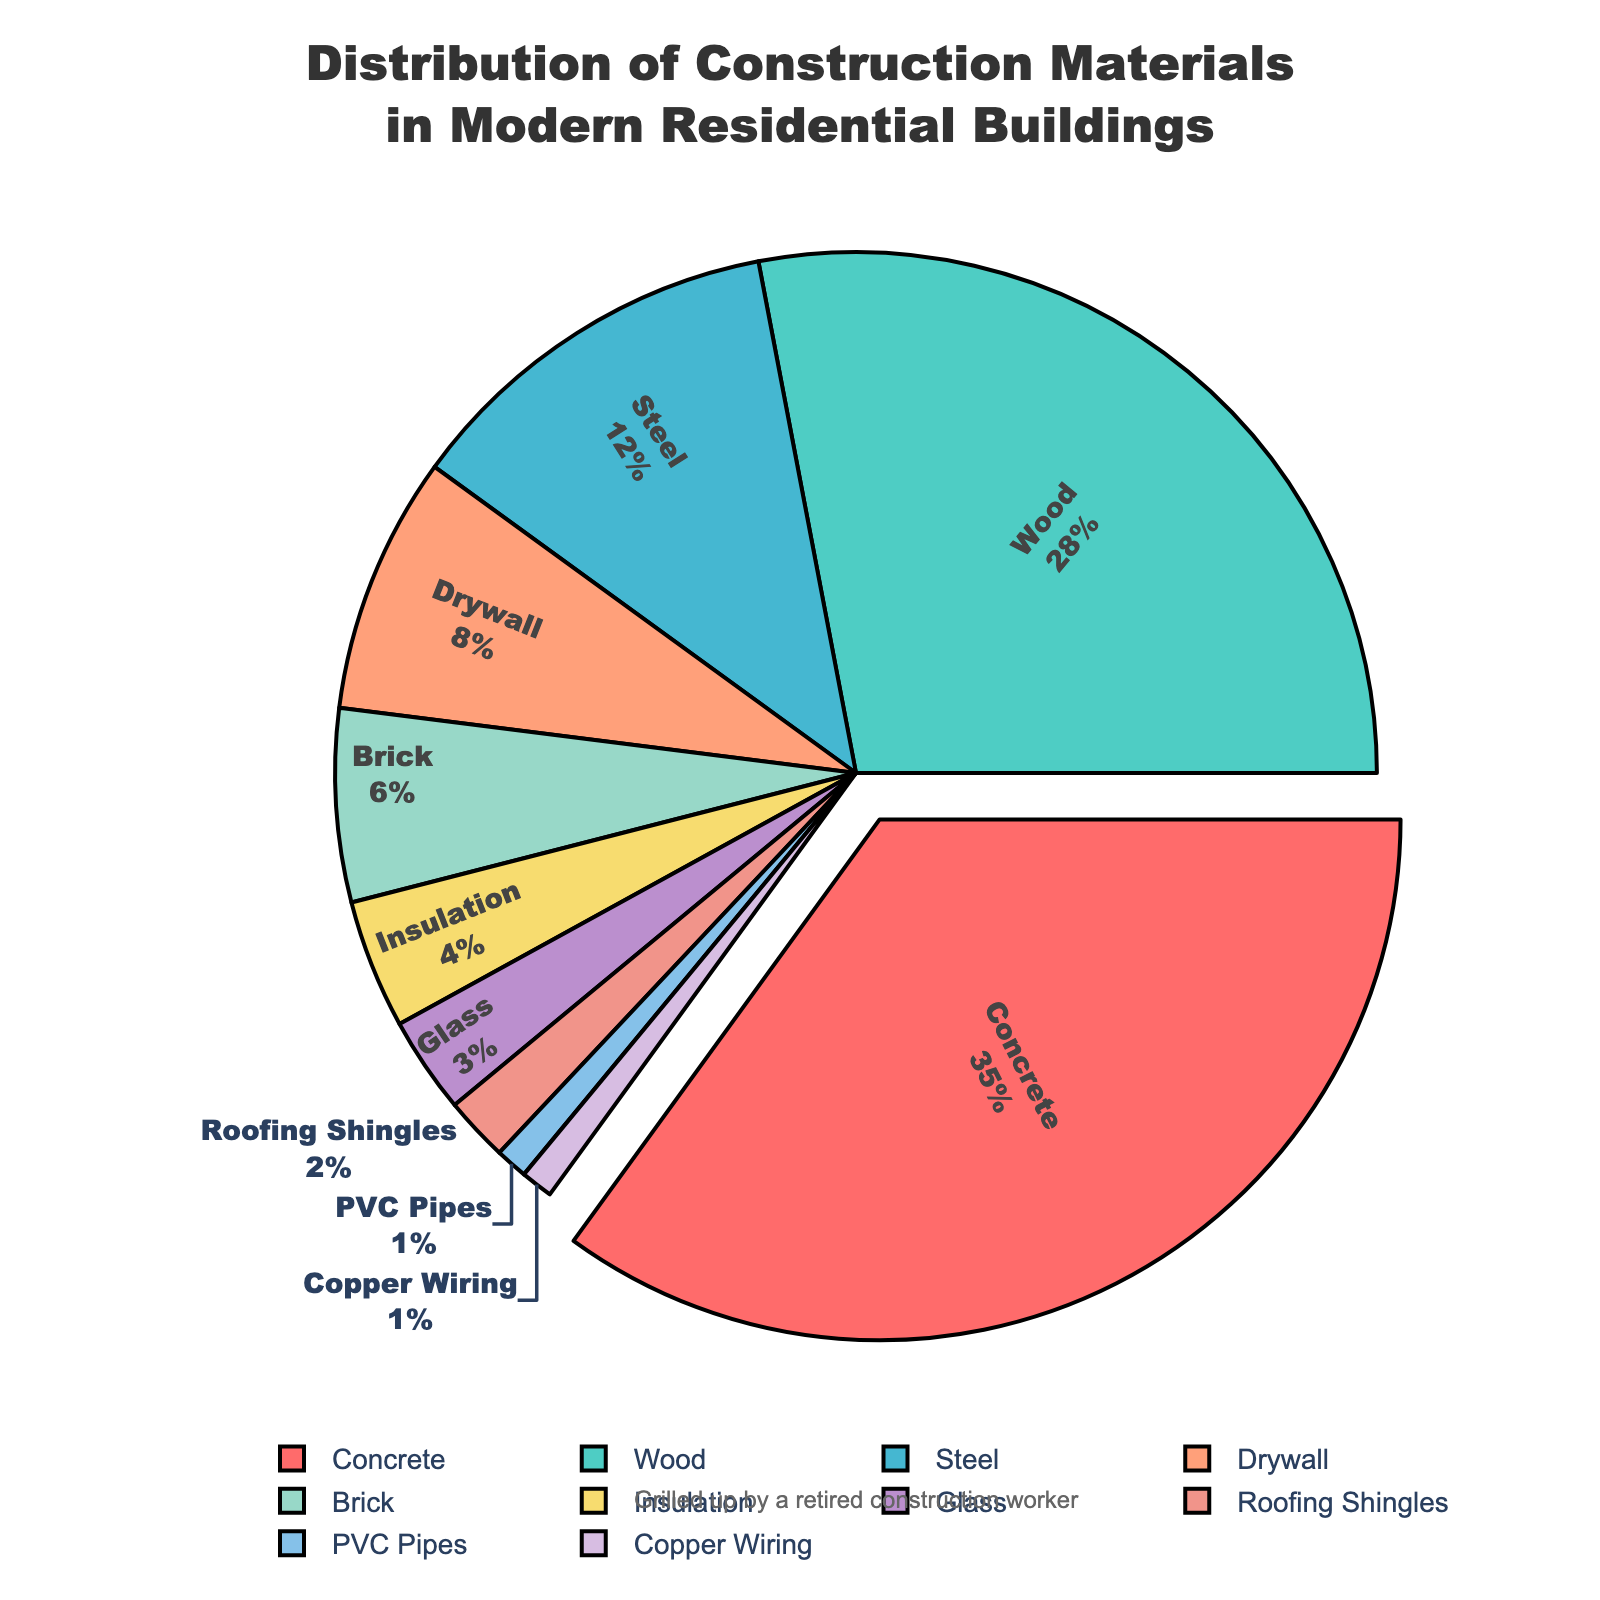What percentage of the construction materials used is Concrete? Refer to the segment labeled 'Concrete' in the pie chart which shows a percentage value.
Answer: 35% Which material is used the least in modern residential buildings? Identify the smallest segment in the pie chart and read the corresponding label.
Answer: Copper Wiring and PVC Pipes How much more percentage does Concrete have compared to Wood? Find the percentage values for both Concrete (35%) and Wood (28%) from the chart and calculate the difference: 35% - 28%.
Answer: 7% What is the combined percentage of Brick, Insulation, Glass, and Roofing Shingles? Sum the percentages of Brick (6%), Insulation (4%), Glass (3%), and Roofing Shingles (2%): 6% + 4% + 3% + 2%.
Answer: 15% Which material occupies a larger percentage, Steel or Drywall? Compare the Steel segment (12%) and the Drywall segment (8%) in the pie chart.
Answer: Steel What color represents the material with the highest percentage? Locate the segment with the highest percentage (Concrete at 35%) and observe its color in the pie chart.
Answer: Red How does the percentage of Insulation compare to that of Glass? Compare the percentage values for Insulation (4%) and Glass (3%).
Answer: Insulation is higher What is the average percentage of Steel, Drywall, and Brick? Sum the percentages of Steel (12%), Drywall (8%), and Brick (6%) and divide by 3: (12% + 8% + 6%) / 3.
Answer: 8.67% Which materials are represented by segments smaller than 5%? Identify the segments with percentages below 5%, which are Insulation (4%), Glass (3%), Roofing Shingles (2%), PVC Pipes (1%), and Copper Wiring (1%).
Answer: Insulation, Glass, Roofing Shingles, PVC Pipes, Copper Wiring What is the percentage difference between Wood and Steel? Find the percentage values for Wood (28%) and Steel (12%) and calculate the difference: 28% - 12%.
Answer: 16% 